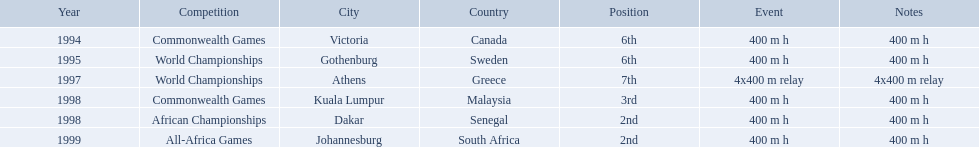What races did ken harden run? 400 m h, 400 m h, 4x400 m relay, 400 m h, 400 m h, 400 m h. Which race did ken harden run in 1997? 4x400 m relay. What country was the 1997 championships held in? Athens, Greece. What long was the relay? 4x400 m relay. 